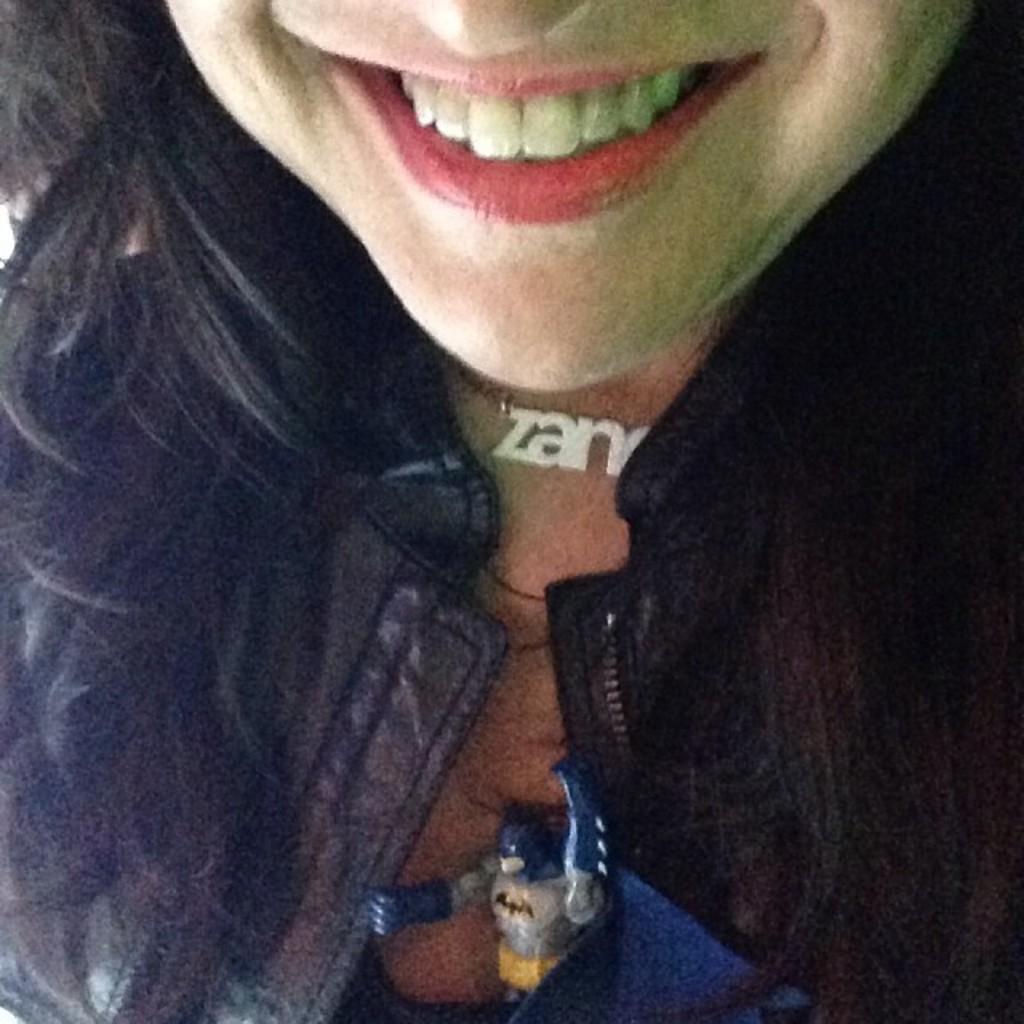In one or two sentences, can you explain what this image depicts? In this picture I can see there is a woman and she is wearing a coat, chain and there is a batman toy. 